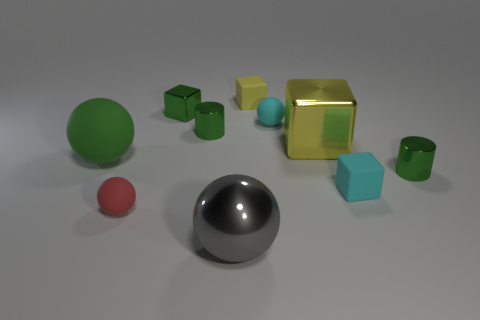Do the large metallic cube and the metallic sphere have the same color?
Offer a very short reply. No. There is a small thing that is the same color as the big metallic cube; what shape is it?
Offer a terse response. Cube. What color is the other big object that is the same shape as the big green object?
Offer a terse response. Gray. How many things are either yellow rubber balls or tiny cyan things?
Give a very brief answer. 2. Does the tiny thing left of the small metal block have the same shape as the tiny thing behind the small green metal block?
Your answer should be very brief. No. What shape is the small cyan matte thing that is on the right side of the large yellow metal thing?
Give a very brief answer. Cube. Are there an equal number of tiny shiny things that are to the left of the gray sphere and cubes on the right side of the yellow rubber thing?
Offer a very short reply. Yes. How many objects are big green matte spheres or small metallic cylinders that are left of the big gray shiny object?
Your answer should be very brief. 2. What shape is the metal object that is both on the right side of the big gray ball and on the left side of the cyan rubber block?
Give a very brief answer. Cube. The green cylinder behind the green shiny cylinder on the right side of the tiny yellow thing is made of what material?
Give a very brief answer. Metal. 